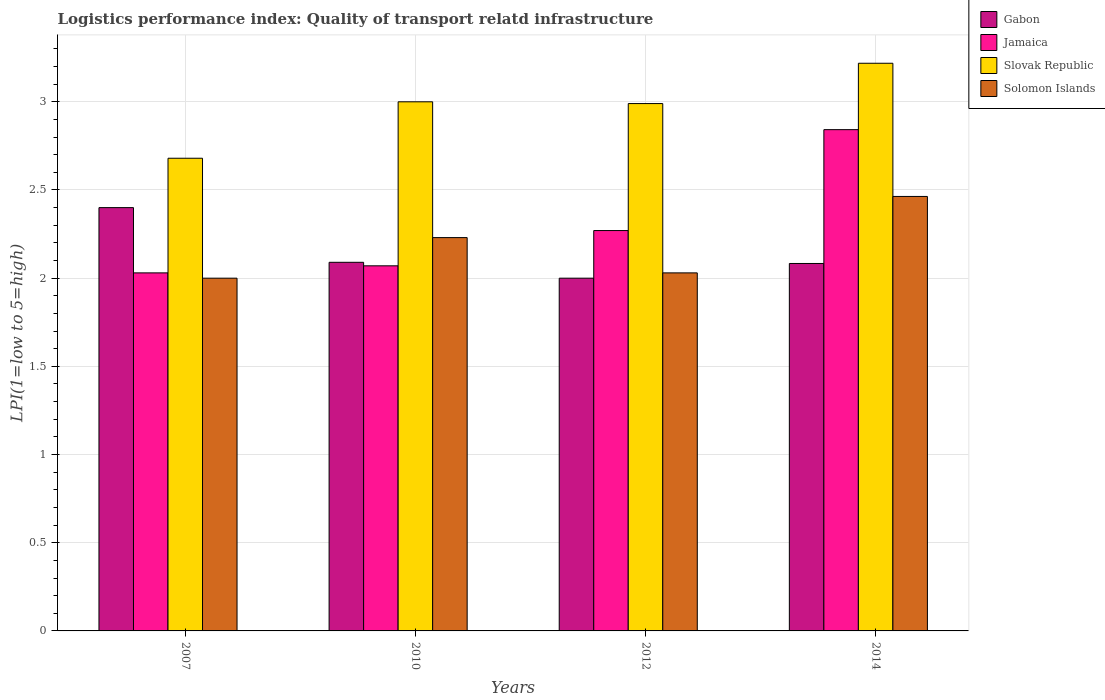How many different coloured bars are there?
Offer a terse response. 4. Are the number of bars on each tick of the X-axis equal?
Ensure brevity in your answer.  Yes. How many bars are there on the 3rd tick from the left?
Make the answer very short. 4. What is the label of the 1st group of bars from the left?
Make the answer very short. 2007. What is the logistics performance index in Jamaica in 2014?
Your answer should be compact. 2.84. Across all years, what is the maximum logistics performance index in Jamaica?
Your answer should be very brief. 2.84. Across all years, what is the minimum logistics performance index in Slovak Republic?
Your answer should be compact. 2.68. In which year was the logistics performance index in Gabon minimum?
Make the answer very short. 2012. What is the total logistics performance index in Slovak Republic in the graph?
Make the answer very short. 11.89. What is the difference between the logistics performance index in Solomon Islands in 2007 and that in 2010?
Provide a short and direct response. -0.23. What is the difference between the logistics performance index in Solomon Islands in 2007 and the logistics performance index in Slovak Republic in 2010?
Keep it short and to the point. -1. What is the average logistics performance index in Jamaica per year?
Give a very brief answer. 2.3. In the year 2014, what is the difference between the logistics performance index in Gabon and logistics performance index in Slovak Republic?
Make the answer very short. -1.14. What is the ratio of the logistics performance index in Slovak Republic in 2007 to that in 2010?
Your response must be concise. 0.89. Is the difference between the logistics performance index in Gabon in 2010 and 2012 greater than the difference between the logistics performance index in Slovak Republic in 2010 and 2012?
Your answer should be very brief. Yes. What is the difference between the highest and the second highest logistics performance index in Slovak Republic?
Your response must be concise. 0.22. What is the difference between the highest and the lowest logistics performance index in Slovak Republic?
Keep it short and to the point. 0.54. In how many years, is the logistics performance index in Solomon Islands greater than the average logistics performance index in Solomon Islands taken over all years?
Your response must be concise. 2. Is the sum of the logistics performance index in Gabon in 2010 and 2014 greater than the maximum logistics performance index in Solomon Islands across all years?
Offer a very short reply. Yes. Is it the case that in every year, the sum of the logistics performance index in Gabon and logistics performance index in Slovak Republic is greater than the sum of logistics performance index in Solomon Islands and logistics performance index in Jamaica?
Your answer should be very brief. No. What does the 3rd bar from the left in 2014 represents?
Offer a terse response. Slovak Republic. What does the 3rd bar from the right in 2012 represents?
Your response must be concise. Jamaica. Are the values on the major ticks of Y-axis written in scientific E-notation?
Provide a short and direct response. No. Does the graph contain any zero values?
Ensure brevity in your answer.  No. Where does the legend appear in the graph?
Your response must be concise. Top right. How many legend labels are there?
Make the answer very short. 4. What is the title of the graph?
Give a very brief answer. Logistics performance index: Quality of transport relatd infrastructure. What is the label or title of the X-axis?
Offer a very short reply. Years. What is the label or title of the Y-axis?
Make the answer very short. LPI(1=low to 5=high). What is the LPI(1=low to 5=high) of Gabon in 2007?
Provide a succinct answer. 2.4. What is the LPI(1=low to 5=high) in Jamaica in 2007?
Provide a short and direct response. 2.03. What is the LPI(1=low to 5=high) of Slovak Republic in 2007?
Your response must be concise. 2.68. What is the LPI(1=low to 5=high) in Gabon in 2010?
Ensure brevity in your answer.  2.09. What is the LPI(1=low to 5=high) in Jamaica in 2010?
Provide a succinct answer. 2.07. What is the LPI(1=low to 5=high) of Solomon Islands in 2010?
Make the answer very short. 2.23. What is the LPI(1=low to 5=high) in Jamaica in 2012?
Provide a short and direct response. 2.27. What is the LPI(1=low to 5=high) in Slovak Republic in 2012?
Provide a succinct answer. 2.99. What is the LPI(1=low to 5=high) in Solomon Islands in 2012?
Provide a succinct answer. 2.03. What is the LPI(1=low to 5=high) of Gabon in 2014?
Ensure brevity in your answer.  2.08. What is the LPI(1=low to 5=high) of Jamaica in 2014?
Your answer should be compact. 2.84. What is the LPI(1=low to 5=high) of Slovak Republic in 2014?
Your response must be concise. 3.22. What is the LPI(1=low to 5=high) of Solomon Islands in 2014?
Offer a very short reply. 2.46. Across all years, what is the maximum LPI(1=low to 5=high) of Gabon?
Your answer should be compact. 2.4. Across all years, what is the maximum LPI(1=low to 5=high) of Jamaica?
Ensure brevity in your answer.  2.84. Across all years, what is the maximum LPI(1=low to 5=high) of Slovak Republic?
Give a very brief answer. 3.22. Across all years, what is the maximum LPI(1=low to 5=high) of Solomon Islands?
Your response must be concise. 2.46. Across all years, what is the minimum LPI(1=low to 5=high) in Jamaica?
Keep it short and to the point. 2.03. Across all years, what is the minimum LPI(1=low to 5=high) of Slovak Republic?
Your answer should be very brief. 2.68. Across all years, what is the minimum LPI(1=low to 5=high) in Solomon Islands?
Give a very brief answer. 2. What is the total LPI(1=low to 5=high) in Gabon in the graph?
Offer a very short reply. 8.57. What is the total LPI(1=low to 5=high) of Jamaica in the graph?
Make the answer very short. 9.21. What is the total LPI(1=low to 5=high) in Slovak Republic in the graph?
Your response must be concise. 11.89. What is the total LPI(1=low to 5=high) in Solomon Islands in the graph?
Offer a very short reply. 8.72. What is the difference between the LPI(1=low to 5=high) of Gabon in 2007 and that in 2010?
Keep it short and to the point. 0.31. What is the difference between the LPI(1=low to 5=high) in Jamaica in 2007 and that in 2010?
Provide a short and direct response. -0.04. What is the difference between the LPI(1=low to 5=high) in Slovak Republic in 2007 and that in 2010?
Your answer should be compact. -0.32. What is the difference between the LPI(1=low to 5=high) in Solomon Islands in 2007 and that in 2010?
Give a very brief answer. -0.23. What is the difference between the LPI(1=low to 5=high) in Jamaica in 2007 and that in 2012?
Provide a short and direct response. -0.24. What is the difference between the LPI(1=low to 5=high) in Slovak Republic in 2007 and that in 2012?
Your answer should be very brief. -0.31. What is the difference between the LPI(1=low to 5=high) of Solomon Islands in 2007 and that in 2012?
Offer a terse response. -0.03. What is the difference between the LPI(1=low to 5=high) in Gabon in 2007 and that in 2014?
Keep it short and to the point. 0.32. What is the difference between the LPI(1=low to 5=high) of Jamaica in 2007 and that in 2014?
Ensure brevity in your answer.  -0.81. What is the difference between the LPI(1=low to 5=high) of Slovak Republic in 2007 and that in 2014?
Your answer should be compact. -0.54. What is the difference between the LPI(1=low to 5=high) in Solomon Islands in 2007 and that in 2014?
Your response must be concise. -0.46. What is the difference between the LPI(1=low to 5=high) in Gabon in 2010 and that in 2012?
Provide a short and direct response. 0.09. What is the difference between the LPI(1=low to 5=high) of Solomon Islands in 2010 and that in 2012?
Give a very brief answer. 0.2. What is the difference between the LPI(1=low to 5=high) of Gabon in 2010 and that in 2014?
Ensure brevity in your answer.  0.01. What is the difference between the LPI(1=low to 5=high) of Jamaica in 2010 and that in 2014?
Ensure brevity in your answer.  -0.77. What is the difference between the LPI(1=low to 5=high) of Slovak Republic in 2010 and that in 2014?
Your response must be concise. -0.22. What is the difference between the LPI(1=low to 5=high) in Solomon Islands in 2010 and that in 2014?
Ensure brevity in your answer.  -0.23. What is the difference between the LPI(1=low to 5=high) in Gabon in 2012 and that in 2014?
Make the answer very short. -0.08. What is the difference between the LPI(1=low to 5=high) in Jamaica in 2012 and that in 2014?
Provide a succinct answer. -0.57. What is the difference between the LPI(1=low to 5=high) of Slovak Republic in 2012 and that in 2014?
Offer a very short reply. -0.23. What is the difference between the LPI(1=low to 5=high) of Solomon Islands in 2012 and that in 2014?
Your answer should be compact. -0.43. What is the difference between the LPI(1=low to 5=high) of Gabon in 2007 and the LPI(1=low to 5=high) of Jamaica in 2010?
Offer a terse response. 0.33. What is the difference between the LPI(1=low to 5=high) in Gabon in 2007 and the LPI(1=low to 5=high) in Solomon Islands in 2010?
Your answer should be very brief. 0.17. What is the difference between the LPI(1=low to 5=high) of Jamaica in 2007 and the LPI(1=low to 5=high) of Slovak Republic in 2010?
Keep it short and to the point. -0.97. What is the difference between the LPI(1=low to 5=high) of Slovak Republic in 2007 and the LPI(1=low to 5=high) of Solomon Islands in 2010?
Offer a very short reply. 0.45. What is the difference between the LPI(1=low to 5=high) in Gabon in 2007 and the LPI(1=low to 5=high) in Jamaica in 2012?
Ensure brevity in your answer.  0.13. What is the difference between the LPI(1=low to 5=high) in Gabon in 2007 and the LPI(1=low to 5=high) in Slovak Republic in 2012?
Ensure brevity in your answer.  -0.59. What is the difference between the LPI(1=low to 5=high) in Gabon in 2007 and the LPI(1=low to 5=high) in Solomon Islands in 2012?
Provide a succinct answer. 0.37. What is the difference between the LPI(1=low to 5=high) of Jamaica in 2007 and the LPI(1=low to 5=high) of Slovak Republic in 2012?
Provide a succinct answer. -0.96. What is the difference between the LPI(1=low to 5=high) of Jamaica in 2007 and the LPI(1=low to 5=high) of Solomon Islands in 2012?
Give a very brief answer. 0. What is the difference between the LPI(1=low to 5=high) in Slovak Republic in 2007 and the LPI(1=low to 5=high) in Solomon Islands in 2012?
Your answer should be compact. 0.65. What is the difference between the LPI(1=low to 5=high) of Gabon in 2007 and the LPI(1=low to 5=high) of Jamaica in 2014?
Provide a short and direct response. -0.44. What is the difference between the LPI(1=low to 5=high) in Gabon in 2007 and the LPI(1=low to 5=high) in Slovak Republic in 2014?
Give a very brief answer. -0.82. What is the difference between the LPI(1=low to 5=high) in Gabon in 2007 and the LPI(1=low to 5=high) in Solomon Islands in 2014?
Offer a terse response. -0.06. What is the difference between the LPI(1=low to 5=high) in Jamaica in 2007 and the LPI(1=low to 5=high) in Slovak Republic in 2014?
Ensure brevity in your answer.  -1.19. What is the difference between the LPI(1=low to 5=high) in Jamaica in 2007 and the LPI(1=low to 5=high) in Solomon Islands in 2014?
Provide a succinct answer. -0.43. What is the difference between the LPI(1=low to 5=high) of Slovak Republic in 2007 and the LPI(1=low to 5=high) of Solomon Islands in 2014?
Provide a succinct answer. 0.22. What is the difference between the LPI(1=low to 5=high) in Gabon in 2010 and the LPI(1=low to 5=high) in Jamaica in 2012?
Your response must be concise. -0.18. What is the difference between the LPI(1=low to 5=high) in Gabon in 2010 and the LPI(1=low to 5=high) in Slovak Republic in 2012?
Provide a short and direct response. -0.9. What is the difference between the LPI(1=low to 5=high) of Gabon in 2010 and the LPI(1=low to 5=high) of Solomon Islands in 2012?
Make the answer very short. 0.06. What is the difference between the LPI(1=low to 5=high) in Jamaica in 2010 and the LPI(1=low to 5=high) in Slovak Republic in 2012?
Make the answer very short. -0.92. What is the difference between the LPI(1=low to 5=high) in Gabon in 2010 and the LPI(1=low to 5=high) in Jamaica in 2014?
Provide a succinct answer. -0.75. What is the difference between the LPI(1=low to 5=high) of Gabon in 2010 and the LPI(1=low to 5=high) of Slovak Republic in 2014?
Keep it short and to the point. -1.13. What is the difference between the LPI(1=low to 5=high) of Gabon in 2010 and the LPI(1=low to 5=high) of Solomon Islands in 2014?
Provide a short and direct response. -0.37. What is the difference between the LPI(1=low to 5=high) of Jamaica in 2010 and the LPI(1=low to 5=high) of Slovak Republic in 2014?
Offer a terse response. -1.15. What is the difference between the LPI(1=low to 5=high) of Jamaica in 2010 and the LPI(1=low to 5=high) of Solomon Islands in 2014?
Keep it short and to the point. -0.39. What is the difference between the LPI(1=low to 5=high) in Slovak Republic in 2010 and the LPI(1=low to 5=high) in Solomon Islands in 2014?
Your response must be concise. 0.54. What is the difference between the LPI(1=low to 5=high) in Gabon in 2012 and the LPI(1=low to 5=high) in Jamaica in 2014?
Ensure brevity in your answer.  -0.84. What is the difference between the LPI(1=low to 5=high) of Gabon in 2012 and the LPI(1=low to 5=high) of Slovak Republic in 2014?
Your answer should be compact. -1.22. What is the difference between the LPI(1=low to 5=high) in Gabon in 2012 and the LPI(1=low to 5=high) in Solomon Islands in 2014?
Provide a succinct answer. -0.46. What is the difference between the LPI(1=low to 5=high) of Jamaica in 2012 and the LPI(1=low to 5=high) of Slovak Republic in 2014?
Your response must be concise. -0.95. What is the difference between the LPI(1=low to 5=high) of Jamaica in 2012 and the LPI(1=low to 5=high) of Solomon Islands in 2014?
Make the answer very short. -0.19. What is the difference between the LPI(1=low to 5=high) in Slovak Republic in 2012 and the LPI(1=low to 5=high) in Solomon Islands in 2014?
Your answer should be compact. 0.53. What is the average LPI(1=low to 5=high) in Gabon per year?
Your answer should be compact. 2.14. What is the average LPI(1=low to 5=high) of Jamaica per year?
Provide a succinct answer. 2.3. What is the average LPI(1=low to 5=high) in Slovak Republic per year?
Your answer should be compact. 2.97. What is the average LPI(1=low to 5=high) in Solomon Islands per year?
Ensure brevity in your answer.  2.18. In the year 2007, what is the difference between the LPI(1=low to 5=high) of Gabon and LPI(1=low to 5=high) of Jamaica?
Offer a very short reply. 0.37. In the year 2007, what is the difference between the LPI(1=low to 5=high) in Gabon and LPI(1=low to 5=high) in Slovak Republic?
Offer a terse response. -0.28. In the year 2007, what is the difference between the LPI(1=low to 5=high) in Gabon and LPI(1=low to 5=high) in Solomon Islands?
Provide a short and direct response. 0.4. In the year 2007, what is the difference between the LPI(1=low to 5=high) of Jamaica and LPI(1=low to 5=high) of Slovak Republic?
Provide a succinct answer. -0.65. In the year 2007, what is the difference between the LPI(1=low to 5=high) of Jamaica and LPI(1=low to 5=high) of Solomon Islands?
Ensure brevity in your answer.  0.03. In the year 2007, what is the difference between the LPI(1=low to 5=high) of Slovak Republic and LPI(1=low to 5=high) of Solomon Islands?
Your answer should be very brief. 0.68. In the year 2010, what is the difference between the LPI(1=low to 5=high) in Gabon and LPI(1=low to 5=high) in Slovak Republic?
Give a very brief answer. -0.91. In the year 2010, what is the difference between the LPI(1=low to 5=high) in Gabon and LPI(1=low to 5=high) in Solomon Islands?
Your answer should be compact. -0.14. In the year 2010, what is the difference between the LPI(1=low to 5=high) in Jamaica and LPI(1=low to 5=high) in Slovak Republic?
Provide a short and direct response. -0.93. In the year 2010, what is the difference between the LPI(1=low to 5=high) in Jamaica and LPI(1=low to 5=high) in Solomon Islands?
Offer a terse response. -0.16. In the year 2010, what is the difference between the LPI(1=low to 5=high) in Slovak Republic and LPI(1=low to 5=high) in Solomon Islands?
Keep it short and to the point. 0.77. In the year 2012, what is the difference between the LPI(1=low to 5=high) in Gabon and LPI(1=low to 5=high) in Jamaica?
Offer a very short reply. -0.27. In the year 2012, what is the difference between the LPI(1=low to 5=high) in Gabon and LPI(1=low to 5=high) in Slovak Republic?
Give a very brief answer. -0.99. In the year 2012, what is the difference between the LPI(1=low to 5=high) in Gabon and LPI(1=low to 5=high) in Solomon Islands?
Offer a very short reply. -0.03. In the year 2012, what is the difference between the LPI(1=low to 5=high) in Jamaica and LPI(1=low to 5=high) in Slovak Republic?
Provide a succinct answer. -0.72. In the year 2012, what is the difference between the LPI(1=low to 5=high) of Jamaica and LPI(1=low to 5=high) of Solomon Islands?
Your answer should be compact. 0.24. In the year 2014, what is the difference between the LPI(1=low to 5=high) in Gabon and LPI(1=low to 5=high) in Jamaica?
Ensure brevity in your answer.  -0.76. In the year 2014, what is the difference between the LPI(1=low to 5=high) of Gabon and LPI(1=low to 5=high) of Slovak Republic?
Ensure brevity in your answer.  -1.14. In the year 2014, what is the difference between the LPI(1=low to 5=high) in Gabon and LPI(1=low to 5=high) in Solomon Islands?
Your answer should be very brief. -0.38. In the year 2014, what is the difference between the LPI(1=low to 5=high) of Jamaica and LPI(1=low to 5=high) of Slovak Republic?
Provide a succinct answer. -0.38. In the year 2014, what is the difference between the LPI(1=low to 5=high) in Jamaica and LPI(1=low to 5=high) in Solomon Islands?
Your response must be concise. 0.38. In the year 2014, what is the difference between the LPI(1=low to 5=high) of Slovak Republic and LPI(1=low to 5=high) of Solomon Islands?
Keep it short and to the point. 0.76. What is the ratio of the LPI(1=low to 5=high) of Gabon in 2007 to that in 2010?
Your response must be concise. 1.15. What is the ratio of the LPI(1=low to 5=high) of Jamaica in 2007 to that in 2010?
Keep it short and to the point. 0.98. What is the ratio of the LPI(1=low to 5=high) in Slovak Republic in 2007 to that in 2010?
Give a very brief answer. 0.89. What is the ratio of the LPI(1=low to 5=high) in Solomon Islands in 2007 to that in 2010?
Keep it short and to the point. 0.9. What is the ratio of the LPI(1=low to 5=high) in Gabon in 2007 to that in 2012?
Provide a short and direct response. 1.2. What is the ratio of the LPI(1=low to 5=high) of Jamaica in 2007 to that in 2012?
Keep it short and to the point. 0.89. What is the ratio of the LPI(1=low to 5=high) of Slovak Republic in 2007 to that in 2012?
Your answer should be very brief. 0.9. What is the ratio of the LPI(1=low to 5=high) of Solomon Islands in 2007 to that in 2012?
Keep it short and to the point. 0.99. What is the ratio of the LPI(1=low to 5=high) of Gabon in 2007 to that in 2014?
Provide a succinct answer. 1.15. What is the ratio of the LPI(1=low to 5=high) of Slovak Republic in 2007 to that in 2014?
Offer a terse response. 0.83. What is the ratio of the LPI(1=low to 5=high) in Solomon Islands in 2007 to that in 2014?
Offer a very short reply. 0.81. What is the ratio of the LPI(1=low to 5=high) in Gabon in 2010 to that in 2012?
Your answer should be compact. 1.04. What is the ratio of the LPI(1=low to 5=high) in Jamaica in 2010 to that in 2012?
Give a very brief answer. 0.91. What is the ratio of the LPI(1=low to 5=high) in Solomon Islands in 2010 to that in 2012?
Offer a very short reply. 1.1. What is the ratio of the LPI(1=low to 5=high) in Gabon in 2010 to that in 2014?
Give a very brief answer. 1. What is the ratio of the LPI(1=low to 5=high) in Jamaica in 2010 to that in 2014?
Keep it short and to the point. 0.73. What is the ratio of the LPI(1=low to 5=high) of Slovak Republic in 2010 to that in 2014?
Provide a succinct answer. 0.93. What is the ratio of the LPI(1=low to 5=high) of Solomon Islands in 2010 to that in 2014?
Your answer should be compact. 0.91. What is the ratio of the LPI(1=low to 5=high) in Gabon in 2012 to that in 2014?
Give a very brief answer. 0.96. What is the ratio of the LPI(1=low to 5=high) in Jamaica in 2012 to that in 2014?
Provide a short and direct response. 0.8. What is the ratio of the LPI(1=low to 5=high) in Slovak Republic in 2012 to that in 2014?
Provide a succinct answer. 0.93. What is the ratio of the LPI(1=low to 5=high) of Solomon Islands in 2012 to that in 2014?
Ensure brevity in your answer.  0.82. What is the difference between the highest and the second highest LPI(1=low to 5=high) in Gabon?
Offer a very short reply. 0.31. What is the difference between the highest and the second highest LPI(1=low to 5=high) of Jamaica?
Provide a succinct answer. 0.57. What is the difference between the highest and the second highest LPI(1=low to 5=high) in Slovak Republic?
Ensure brevity in your answer.  0.22. What is the difference between the highest and the second highest LPI(1=low to 5=high) of Solomon Islands?
Provide a succinct answer. 0.23. What is the difference between the highest and the lowest LPI(1=low to 5=high) of Gabon?
Make the answer very short. 0.4. What is the difference between the highest and the lowest LPI(1=low to 5=high) of Jamaica?
Make the answer very short. 0.81. What is the difference between the highest and the lowest LPI(1=low to 5=high) of Slovak Republic?
Provide a short and direct response. 0.54. What is the difference between the highest and the lowest LPI(1=low to 5=high) in Solomon Islands?
Ensure brevity in your answer.  0.46. 